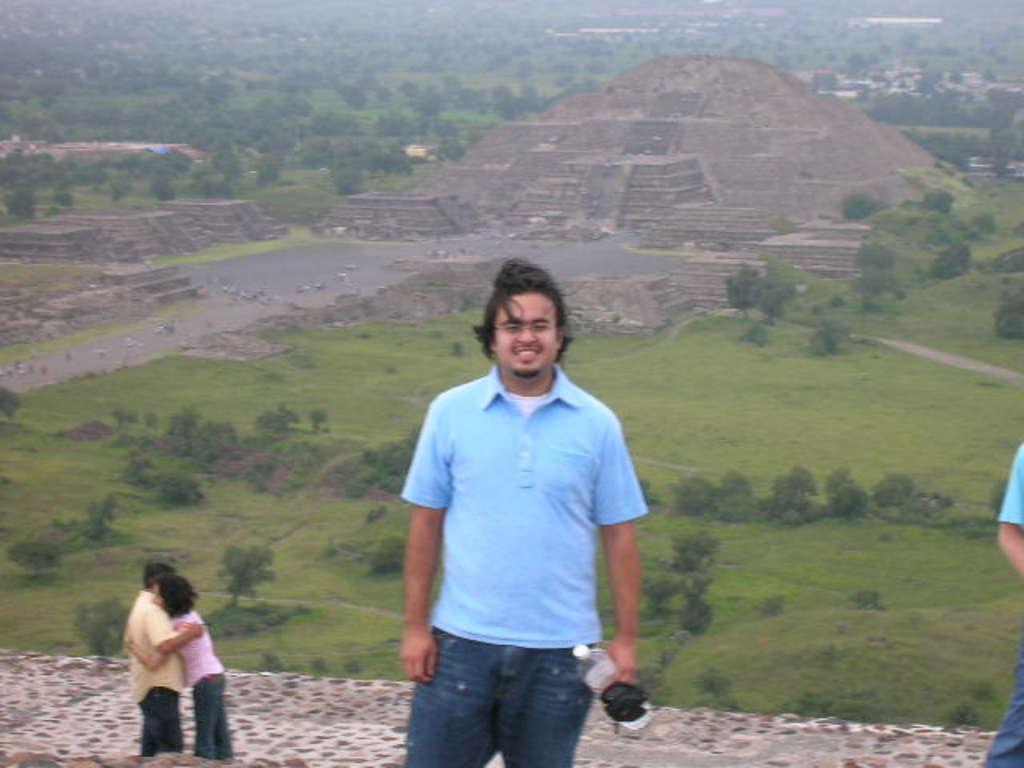Could you give a brief overview of what you see in this image? In this image there is a person standing and smiling by holding a bottle, three persons standing, and in the background there are trees, kind of pyramid. 